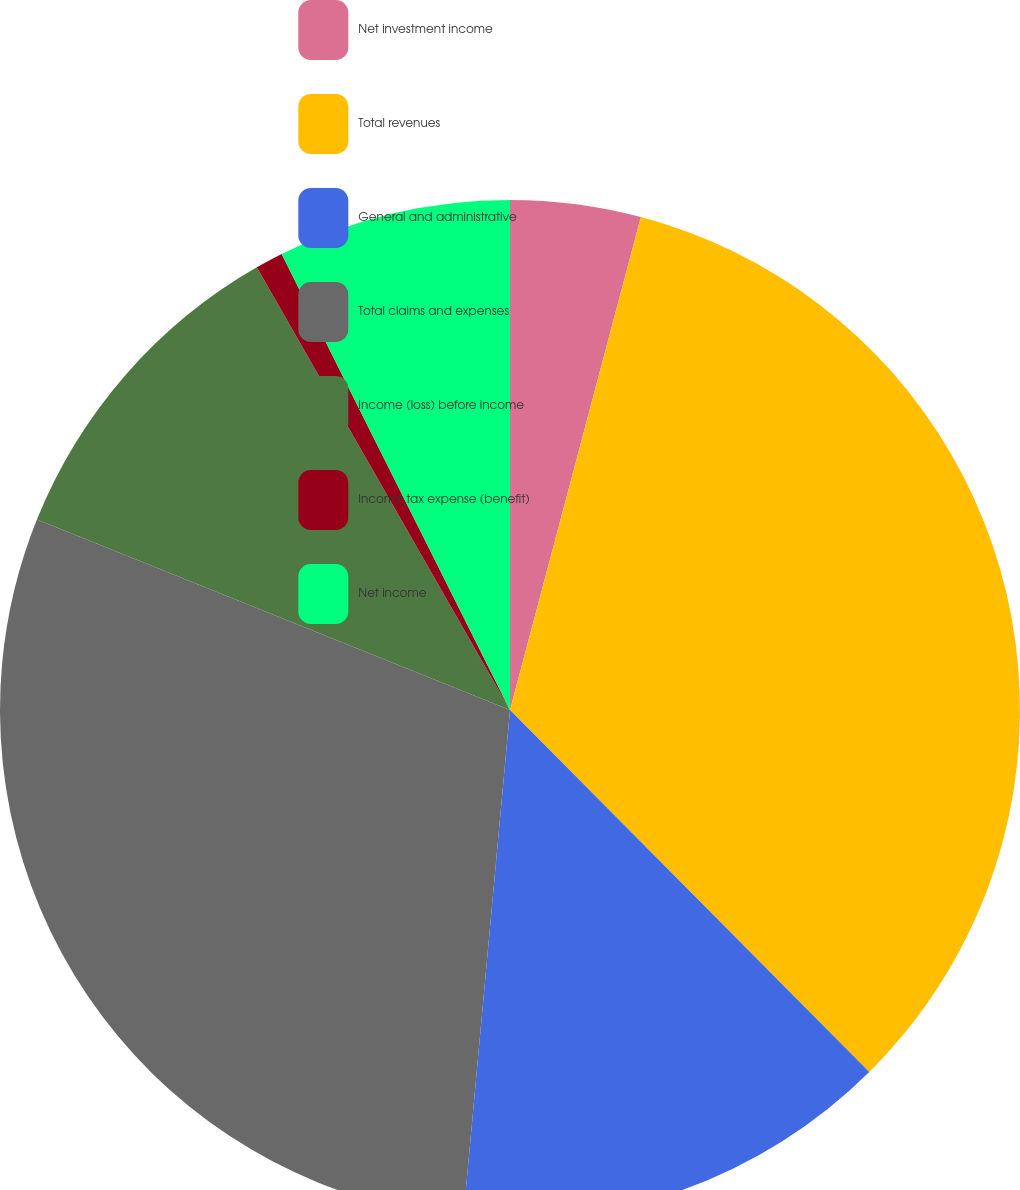Convert chart to OTSL. <chart><loc_0><loc_0><loc_500><loc_500><pie_chart><fcel>Net investment income<fcel>Total revenues<fcel>General and administrative<fcel>Total claims and expenses<fcel>Income (loss) before income<fcel>Income tax expense (benefit)<fcel>Net income<nl><fcel>4.13%<fcel>33.43%<fcel>13.9%<fcel>29.63%<fcel>10.64%<fcel>0.88%<fcel>7.39%<nl></chart> 